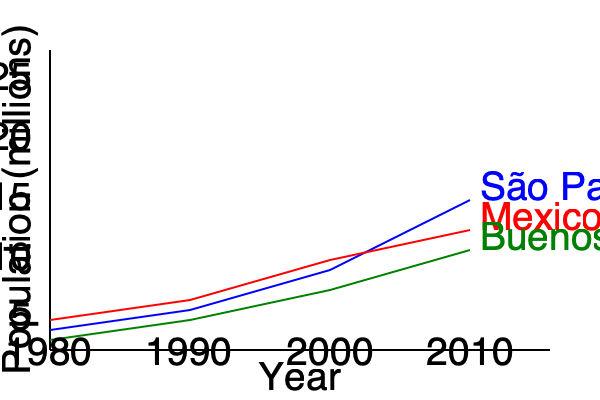Based on the line graph showing population growth trends in three major Latin American cities from 1980 to 2010, which city experienced the most rapid population growth, and what factors might have contributed to this trend? To answer this question, we need to analyze the slopes of the lines for each city:

1. São Paulo (blue line):
   - Starts at about 5 million in 1980
   - Ends at about 20 million in 2010
   - Shows a steep, consistent upward trend

2. Mexico City (red line):
   - Starts slightly below São Paulo in 1980
   - Ends at about 15 million in 2010
   - Shows a moderate upward trend, less steep than São Paulo

3. Buenos Aires (green line):
   - Starts at about 4 million in 1980
   - Ends at about 13 million in 2010
   - Shows the gentlest upward slope among the three cities

Comparing the slopes, São Paulo clearly shows the steepest incline, indicating the most rapid population growth.

Factors contributing to São Paulo's rapid growth might include:

1. Economic opportunities: São Paulo is Brazil's economic powerhouse, attracting migrants from rural areas and other countries.
2. Industrialization: The city's industrial sector expanded significantly during this period.
3. Natural population growth: High birth rates combined with improving healthcare leading to lower mortality rates.
4. Urban expansion: The city's metropolitan area grew, incorporating nearby municipalities.
5. Migration policies: Brazil's policies might have been more open to internal and international migration compared to Argentina or Mexico.

To quantify the growth:
São Paulo's population increased by approximately 300% (from ~5 million to ~20 million)
Mexico City's population increased by about 200% (from ~5 million to ~15 million)
Buenos Aires' population increased by about 225% (from ~4 million to ~13 million)

This analysis confirms that São Paulo experienced the most rapid population growth among these three major Latin American cities from 1980 to 2010.
Answer: São Paulo, due to economic opportunities, industrialization, natural population growth, urban expansion, and possibly more open migration policies. 